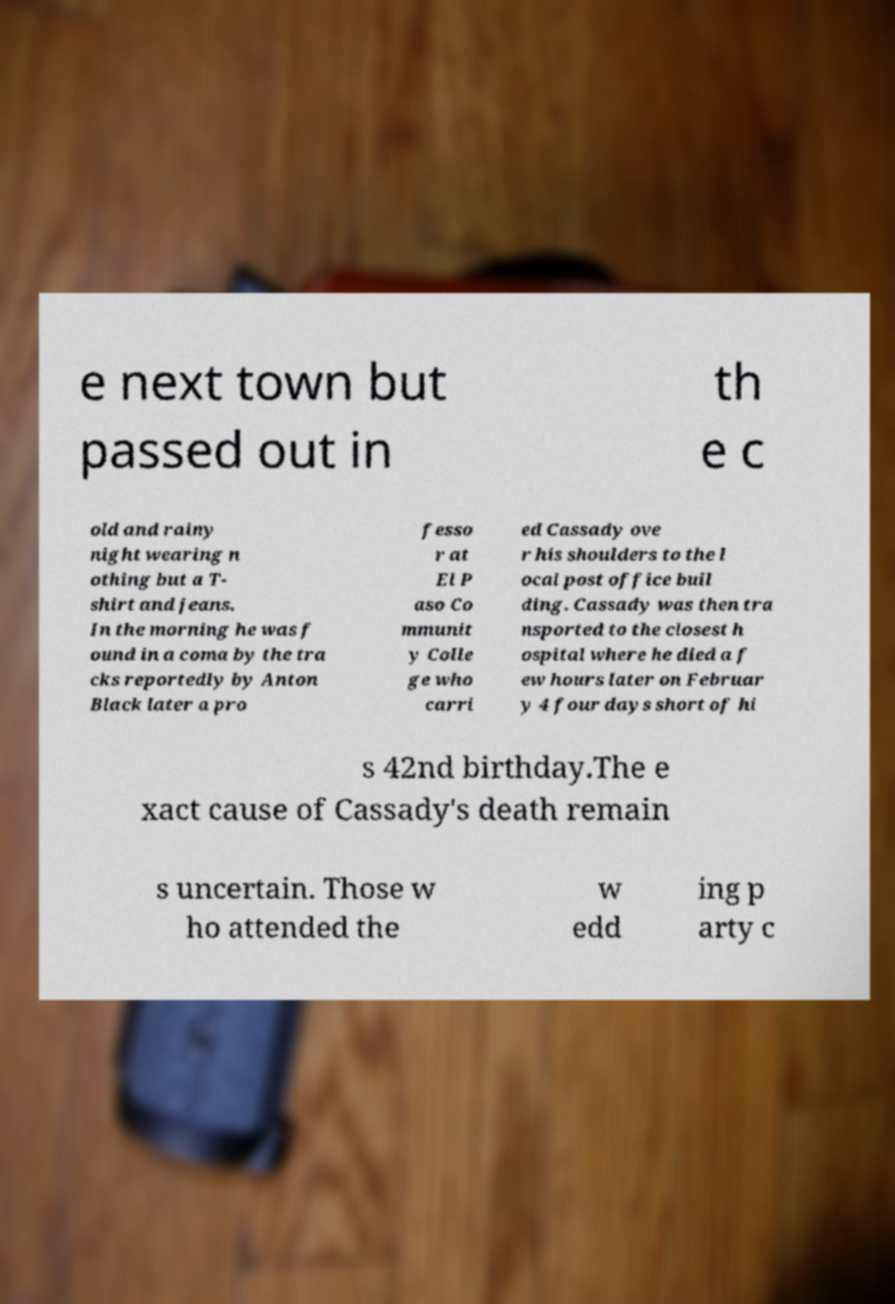Can you accurately transcribe the text from the provided image for me? e next town but passed out in th e c old and rainy night wearing n othing but a T- shirt and jeans. In the morning he was f ound in a coma by the tra cks reportedly by Anton Black later a pro fesso r at El P aso Co mmunit y Colle ge who carri ed Cassady ove r his shoulders to the l ocal post office buil ding. Cassady was then tra nsported to the closest h ospital where he died a f ew hours later on Februar y 4 four days short of hi s 42nd birthday.The e xact cause of Cassady's death remain s uncertain. Those w ho attended the w edd ing p arty c 